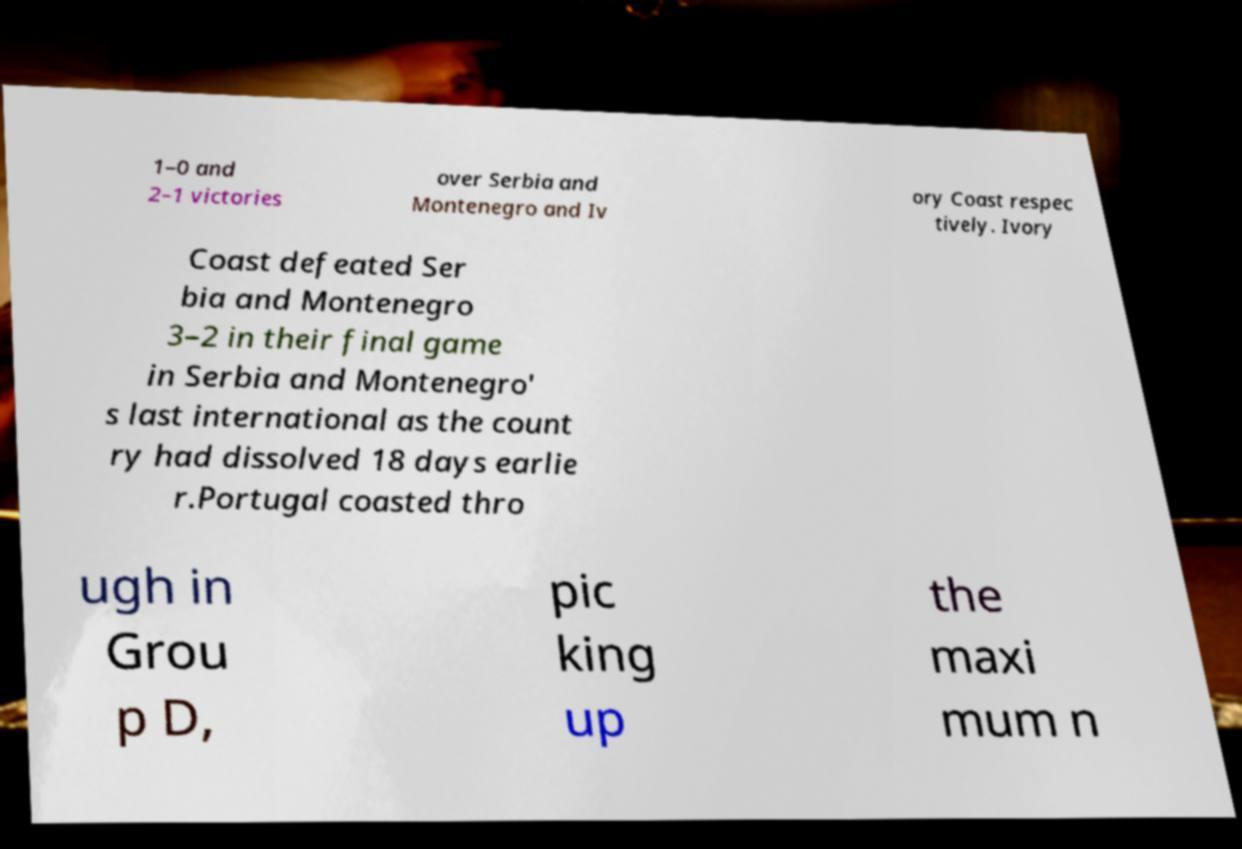Please read and relay the text visible in this image. What does it say? 1–0 and 2–1 victories over Serbia and Montenegro and Iv ory Coast respec tively. Ivory Coast defeated Ser bia and Montenegro 3–2 in their final game in Serbia and Montenegro' s last international as the count ry had dissolved 18 days earlie r.Portugal coasted thro ugh in Grou p D, pic king up the maxi mum n 